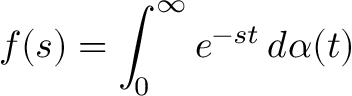<formula> <loc_0><loc_0><loc_500><loc_500>f ( s ) = \int _ { 0 } ^ { \infty } e ^ { - s t } \, d \alpha ( t )</formula> 